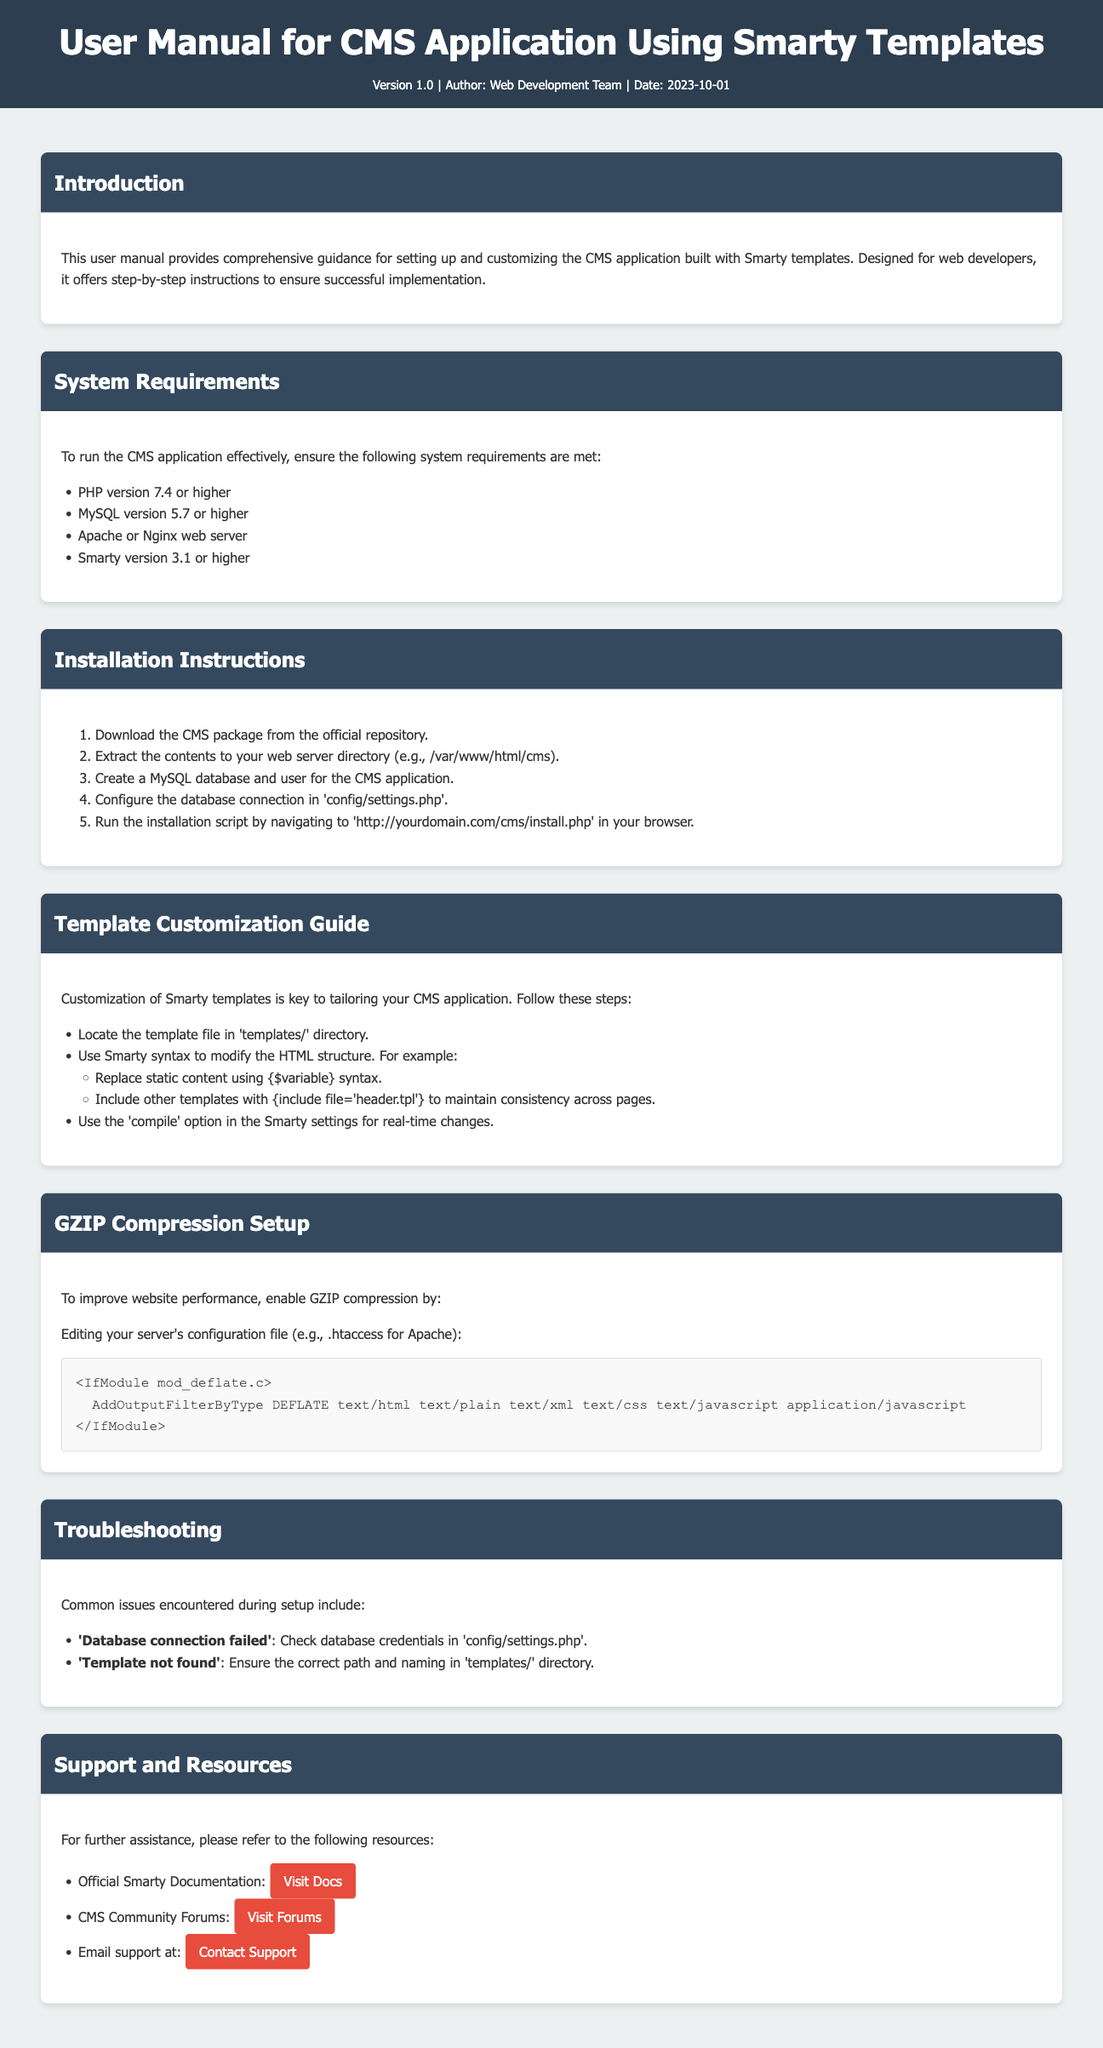What is the version of the user manual? The version of the user manual is stated in the meta-info section of the document as Version 1.0.
Answer: Version 1.0 Who is the author of the user manual? The author is mentioned in the meta-info section, stating it is the Web Development Team.
Answer: Web Development Team What is the minimum required PHP version for the CMS application? The system requirements section specifies that PHP version 7.4 or higher is needed.
Answer: 7.4 What should you edit to enable GZIP compression? The section on GZIP compression indicates that you need to edit your server's configuration file, specifically .htaccess for Apache.
Answer: .htaccess What is one common issue during setup? The troubleshooting section lists common issues and one noted issue is 'Database connection failed'.
Answer: Database connection failed How should you include other templates in Smarty? The template customization guide mentions using the syntax {include file='header.tpl'} to include other templates.
Answer: {include file='header.tpl'} What document type is this user manual intended for? The document type is specified clearly in the title, indicating it is a user manual for a CMS application.
Answer: User Manual What version of Smarty is required? According to the system requirements, Smarty version 3.1 or higher is required for the application.
Answer: 3.1 